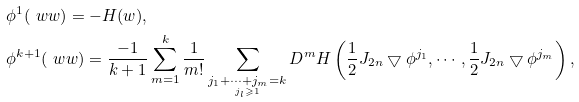<formula> <loc_0><loc_0><loc_500><loc_500>& \phi ^ { 1 } ( \ w w ) = - H ( w ) , \\ & \phi ^ { k + 1 } ( \ w w ) = \frac { - 1 } { k + 1 } \sum _ { m = 1 } ^ { k } \frac { 1 } { m ! } \sum _ { \underset { j _ { l } \geqslant 1 } { j _ { 1 } + \cdots + j _ { m } = k } } D ^ { m } H \left ( \frac { 1 } { 2 } J _ { 2 n } \bigtriangledown \phi ^ { j _ { 1 } } , \cdots , \frac { 1 } { 2 } J _ { 2 n } \bigtriangledown \phi ^ { j _ { m } } \right ) ,</formula> 